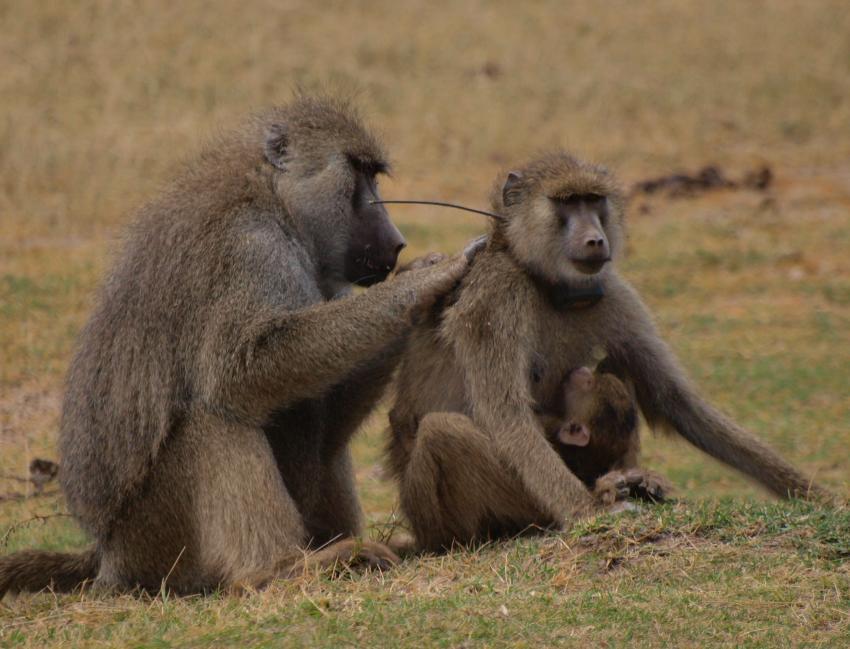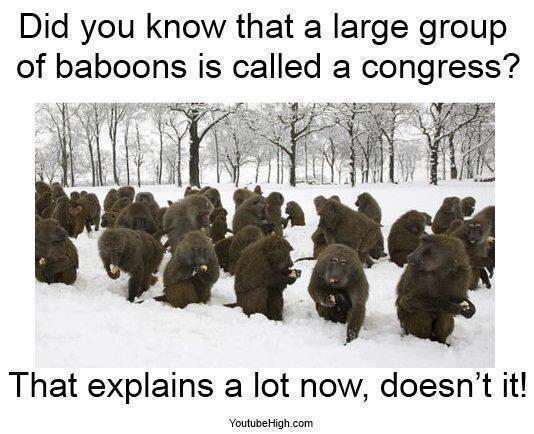The first image is the image on the left, the second image is the image on the right. Assess this claim about the two images: "The animals in the image on the left are near a body of water.". Correct or not? Answer yes or no. No. The first image is the image on the left, the second image is the image on the right. Examine the images to the left and right. Is the description "Right image shows a group of baboons gathered but not closely huddled in a field with plant life present." accurate? Answer yes or no. Yes. 